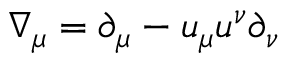<formula> <loc_0><loc_0><loc_500><loc_500>\nabla _ { \mu } = \partial _ { \mu } - u _ { \mu } u ^ { \nu } \partial _ { \nu }</formula> 